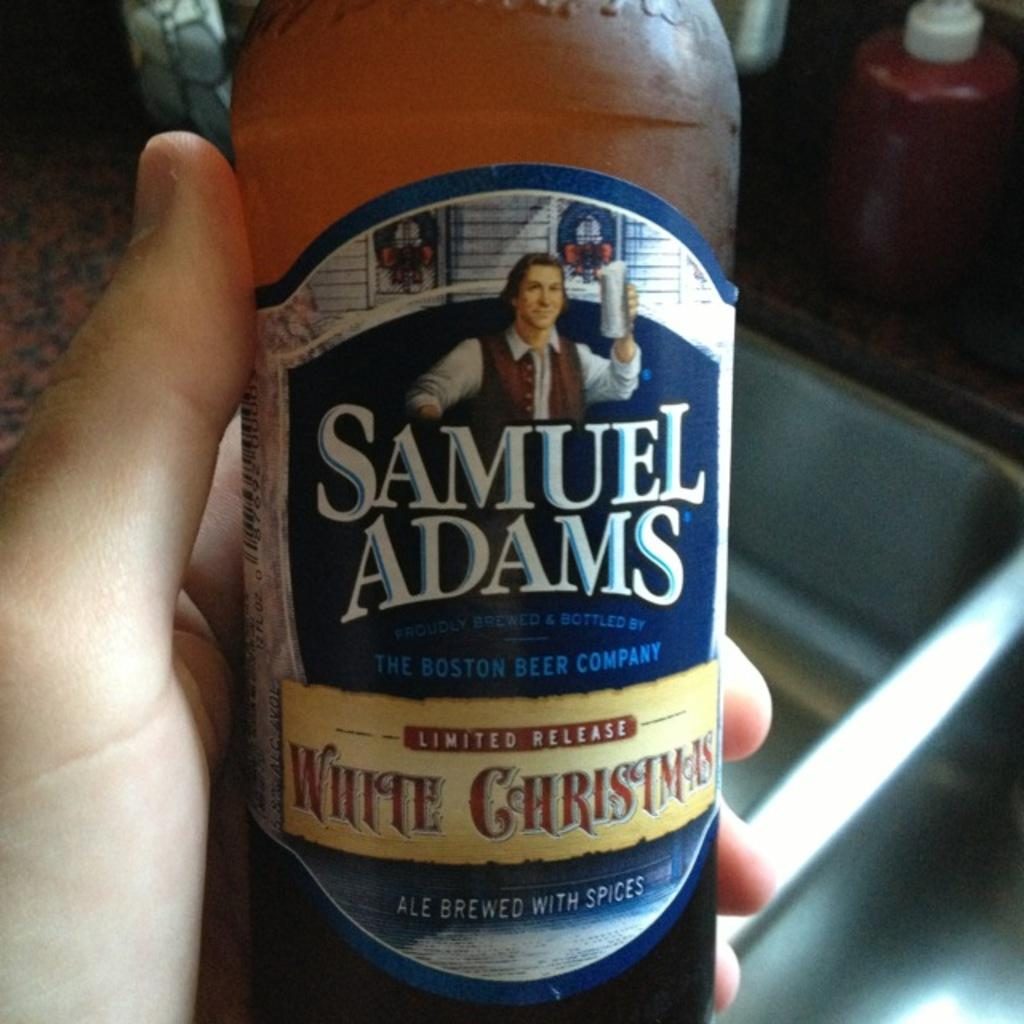Where was the image taken? The image was taken inside a room. Who or what is present in the image? There is a person in the image. What is the person holding in the image? The person is holding a wine bottle. What can be identified from the label on the wine bottle? The label on the wine bottle says "Samuel Adams." How much money is visible in the image? There is no money visible in the image. What type of cup is being used to serve the wine in the image? There is no cup present in the image; the person is holding a wine bottle. 